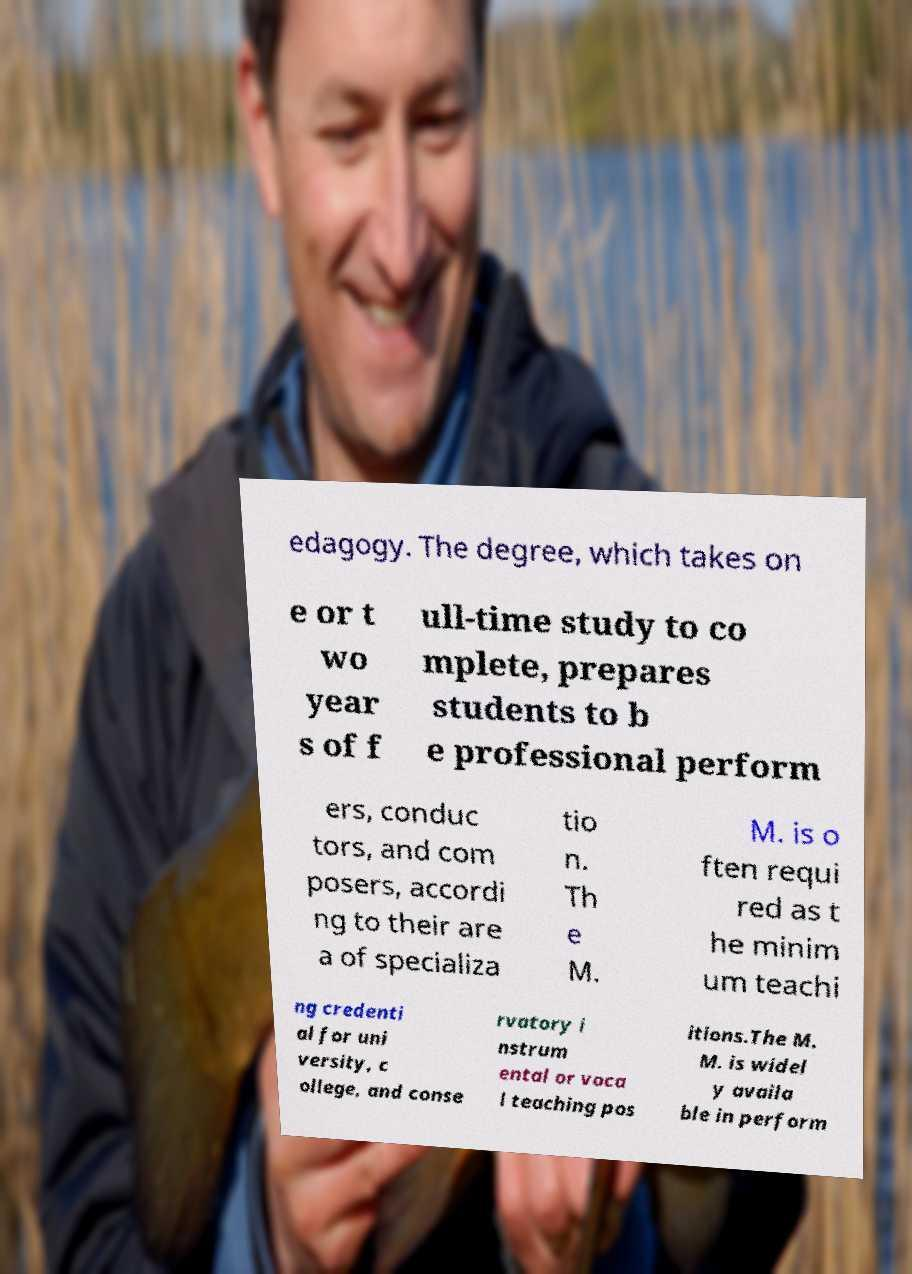Please identify and transcribe the text found in this image. edagogy. The degree, which takes on e or t wo year s of f ull-time study to co mplete, prepares students to b e professional perform ers, conduc tors, and com posers, accordi ng to their are a of specializa tio n. Th e M. M. is o ften requi red as t he minim um teachi ng credenti al for uni versity, c ollege, and conse rvatory i nstrum ental or voca l teaching pos itions.The M. M. is widel y availa ble in perform 